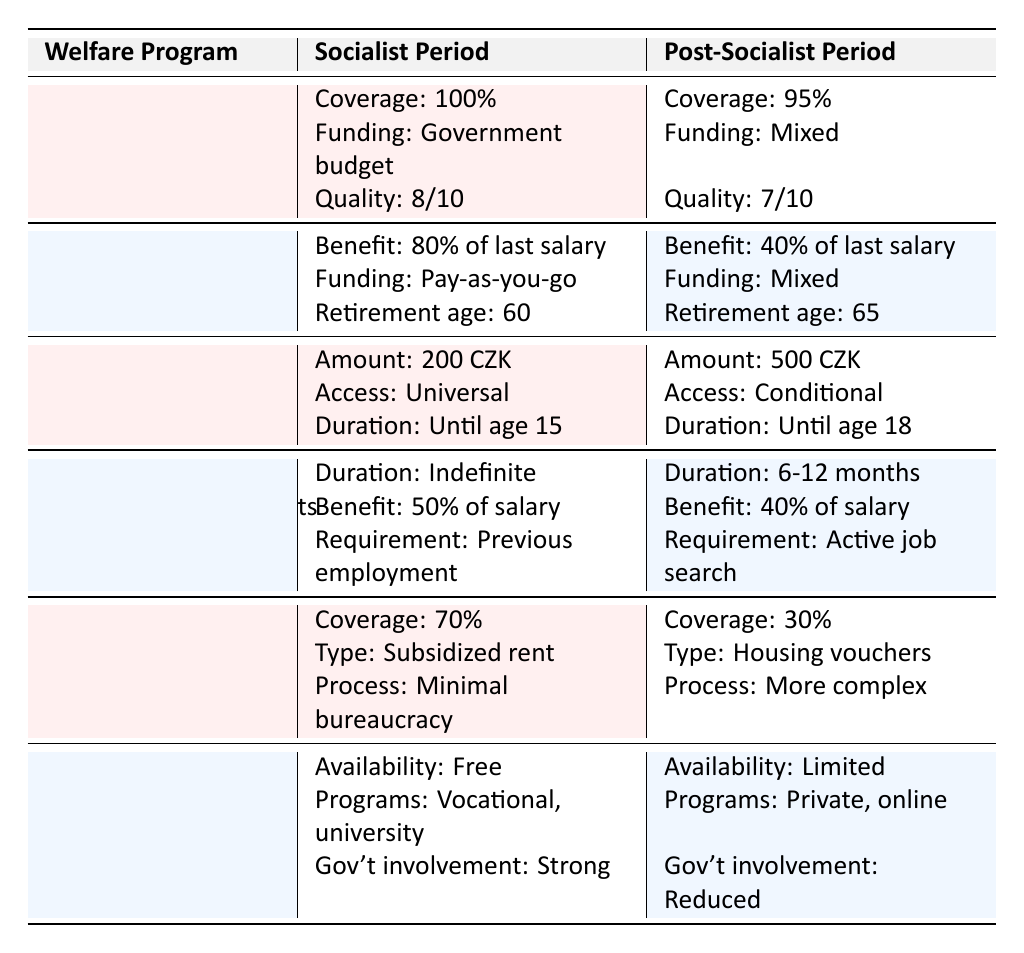What is the coverage percentage of Universal Healthcare during the socialist period? The table indicates that the coverage percentage for Universal Healthcare during the socialist period is listed as 100%.
Answer: 100% How much was the monthly amount for Child Allowance in the post-socialist period? According to the table, the monthly amount for Child Allowance in the post-socialist period is stated as 500 CZK (average).
Answer: 500 CZK Is the funding source for the Pension System during the post-socialist period a mixed funding source? The table confirms that the funding source for the Pension System in the post-socialist period is identified as "Mixed (public and private contributions)," which indicates that it is indeed mixed.
Answer: Yes What is the difference in housing costs covered between socialist and post-socialist periods? The table shows that housing costs were covered at 70% during the socialist period and 30% during the post-socialist period. Thus, the difference is calculated as 70% - 30% = 40%.
Answer: 40% How many extra years do individuals have to work before they can retire in the post-socialist period compared to the socialist period? The retirement age during the socialist period is 60 years, while in the post-socialist period it is 65 years. The difference is 65 - 60 = 5 years.
Answer: 5 years What is the quality rating difference for Universal Healthcare between the socialist and post-socialist periods? The quality rating for Universal Healthcare is 8/10 in the socialist period and 7/10 in the post-socialist period. Thus, the difference is 8/10 - 7/10 = 1/10.
Answer: 1/10 Was the unemployment benefit duration indefinite during the socialist period? The table states that the benefit duration for unemployment benefits in the socialist period is "Indefinite until reemployment," confirming that it was indeed indefinite.
Answer: Yes How does the government involvement in Adult Education programs differ between the two periods? The table indicates that government involvement was strong in the socialist period and reduced in the post-socialist period, showing a clear decrease in government presence.
Answer: Reduced involvement What is the average benefit percentage received from the Pension System in the post-socialist period compared to the socialist period? The table specifies that the pension benefit is 80% of the last salary in the socialist period and 40% in the post-socialist period. The average benefit dropped by 40%.
Answer: Dropped by 40% In total, how many welfare programs show a decrease in coverage or support from socialist to post-socialist periods? Analyzing the table, we can see that the Universal Healthcare, Pension System, Unemployment Benefits, Housing Assistance, and Adult Education all demonstrate a decrease in coverage or support. That totals to five welfare programs.
Answer: Five programs 